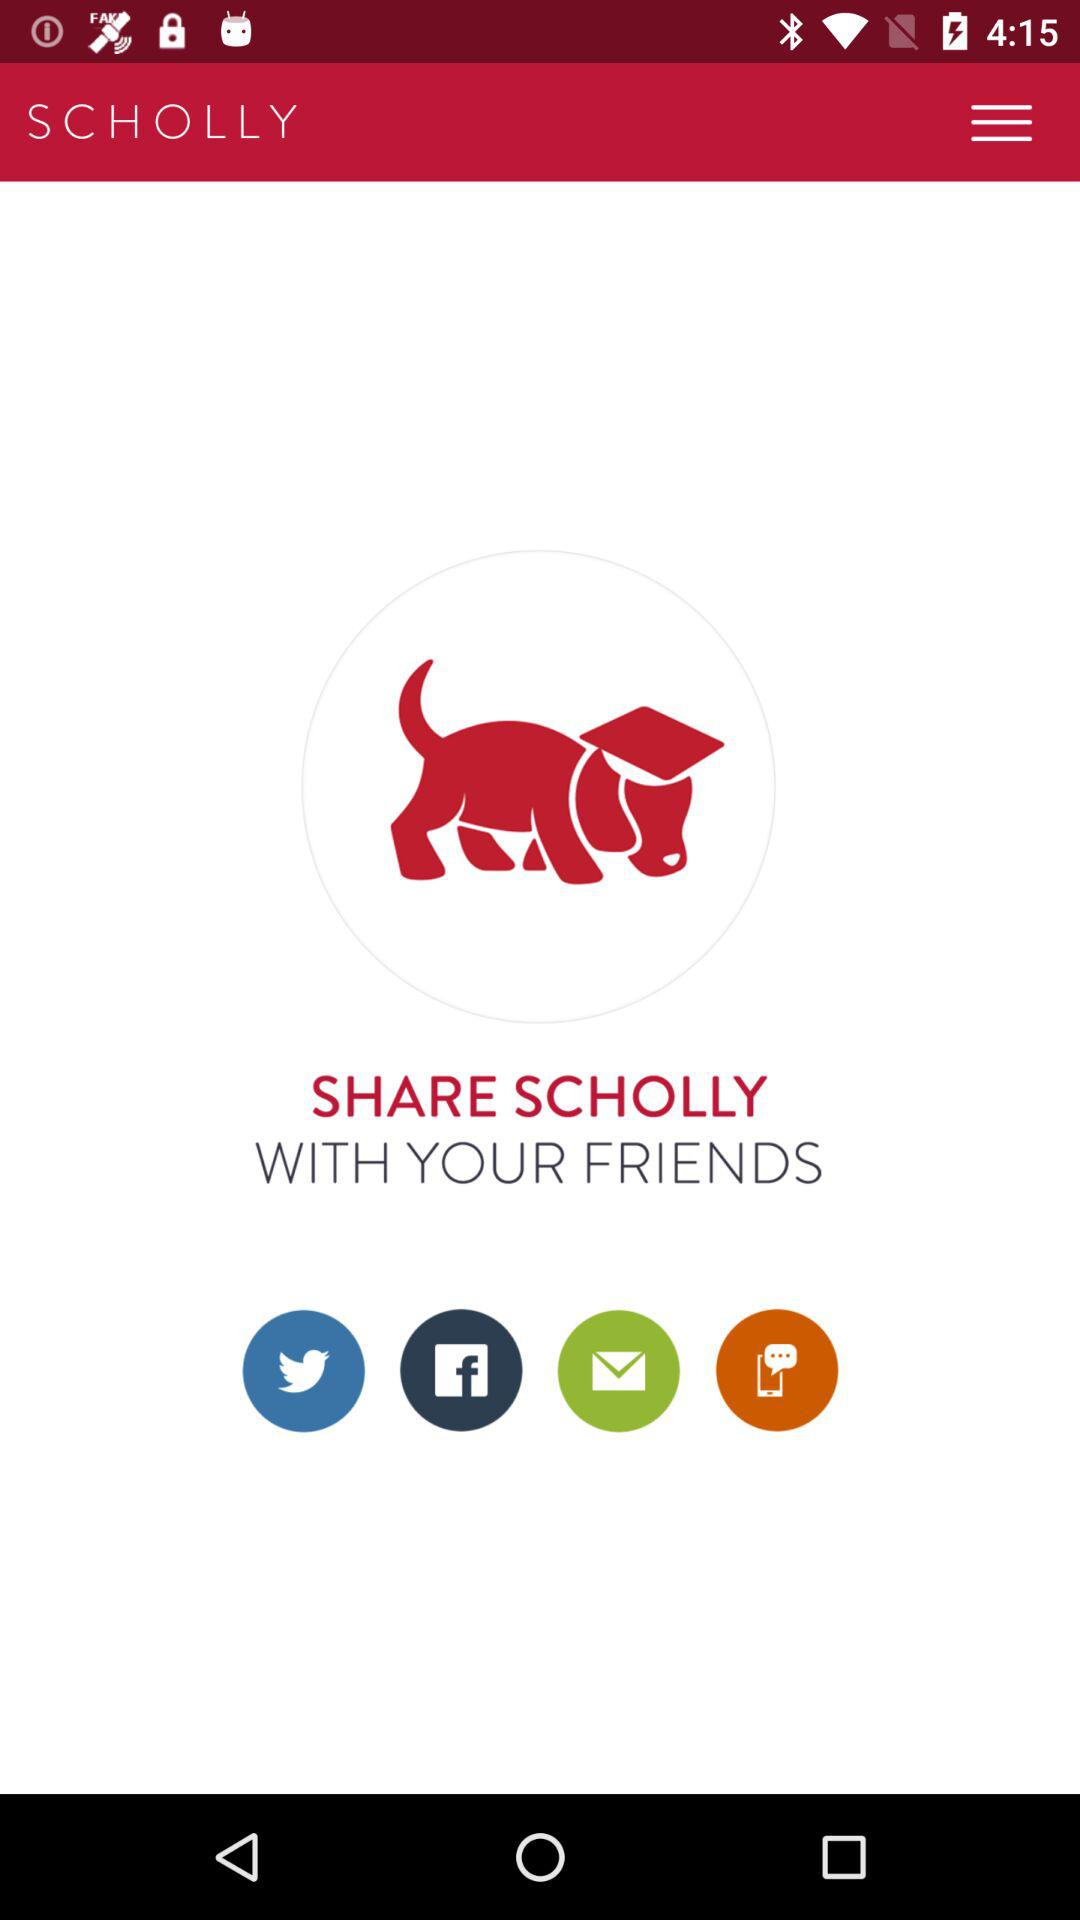What is the name of the application? The name of the application is "SCHOLLY". 